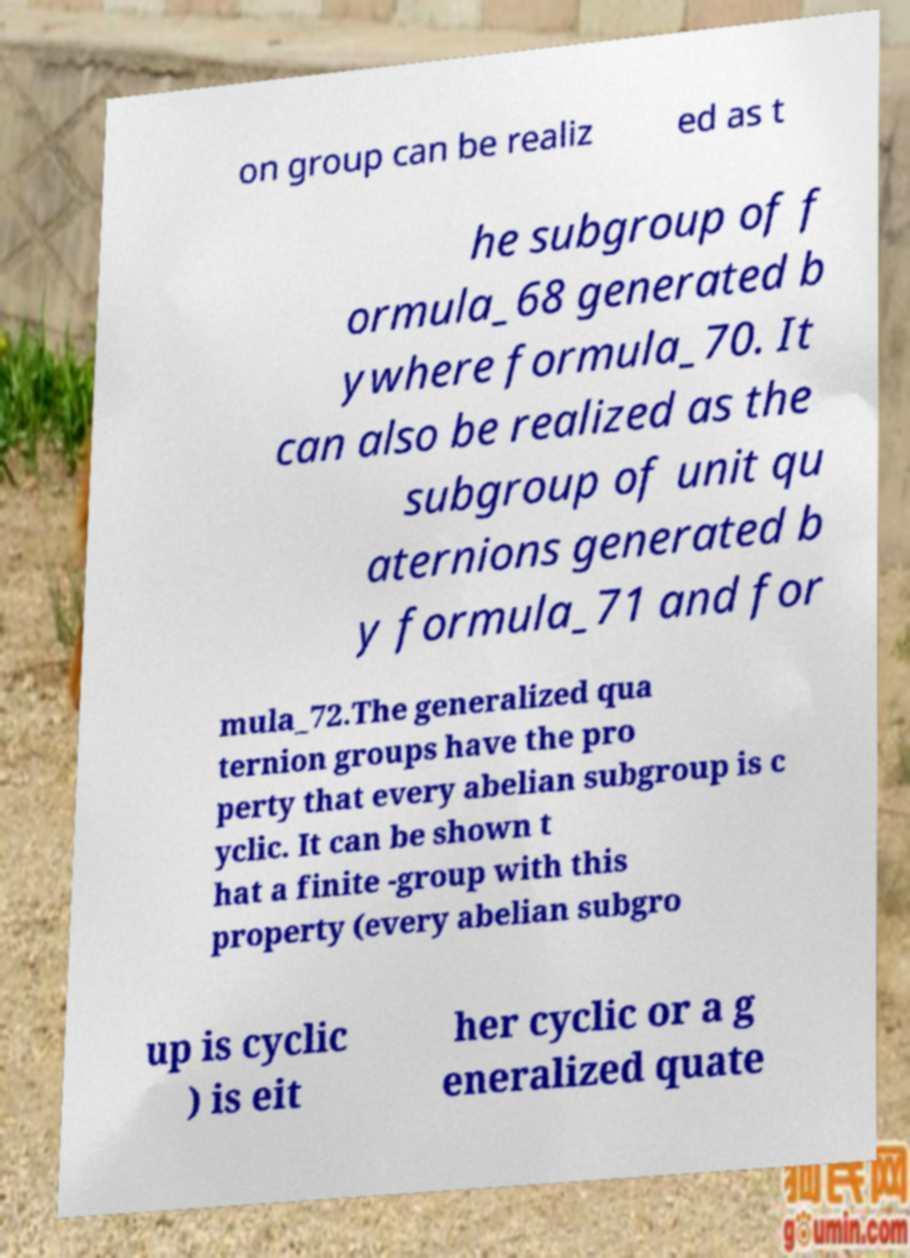Please read and relay the text visible in this image. What does it say? on group can be realiz ed as t he subgroup of f ormula_68 generated b ywhere formula_70. It can also be realized as the subgroup of unit qu aternions generated b y formula_71 and for mula_72.The generalized qua ternion groups have the pro perty that every abelian subgroup is c yclic. It can be shown t hat a finite -group with this property (every abelian subgro up is cyclic ) is eit her cyclic or a g eneralized quate 